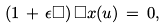<formula> <loc_0><loc_0><loc_500><loc_500>\left ( 1 \, + \, \epsilon \Box \right ) \Box { x } ( u ) \, = \, 0 ,</formula> 